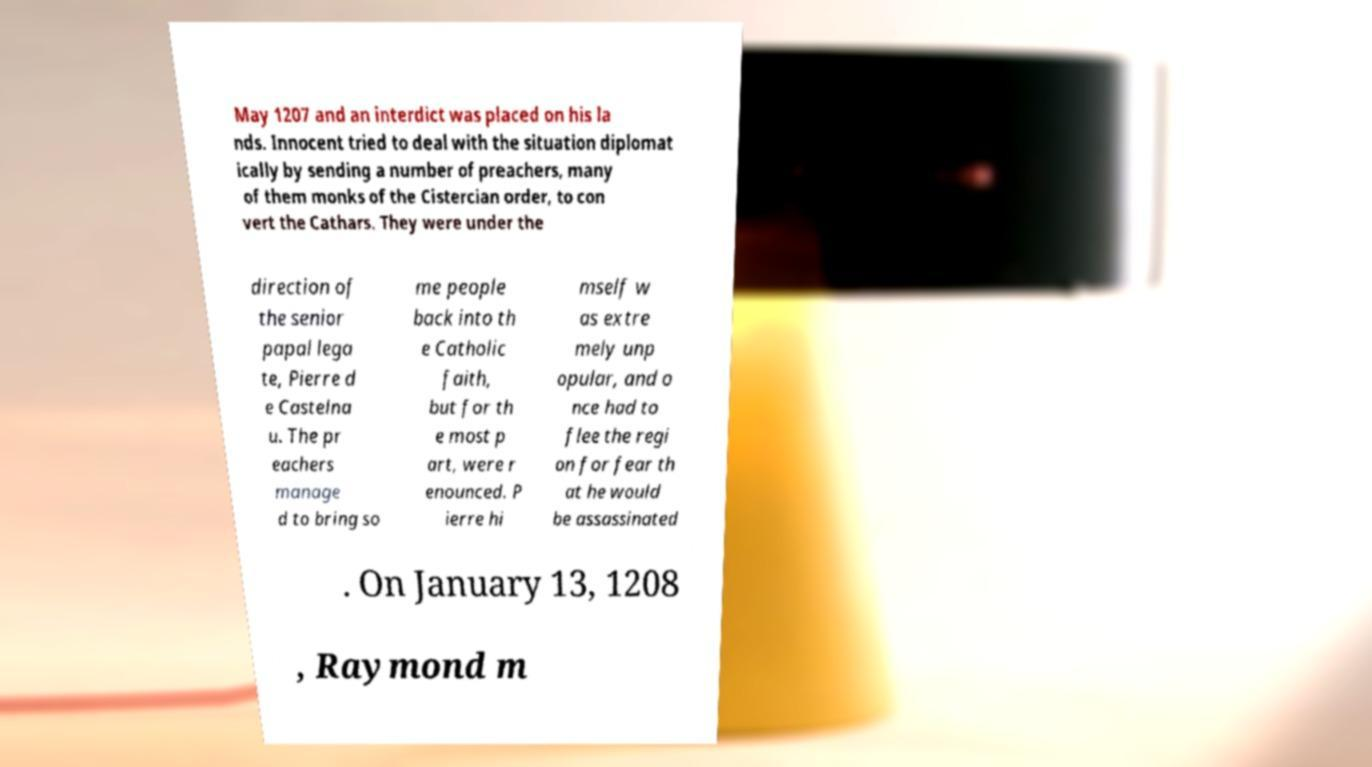I need the written content from this picture converted into text. Can you do that? May 1207 and an interdict was placed on his la nds. Innocent tried to deal with the situation diplomat ically by sending a number of preachers, many of them monks of the Cistercian order, to con vert the Cathars. They were under the direction of the senior papal lega te, Pierre d e Castelna u. The pr eachers manage d to bring so me people back into th e Catholic faith, but for th e most p art, were r enounced. P ierre hi mself w as extre mely unp opular, and o nce had to flee the regi on for fear th at he would be assassinated . On January 13, 1208 , Raymond m 